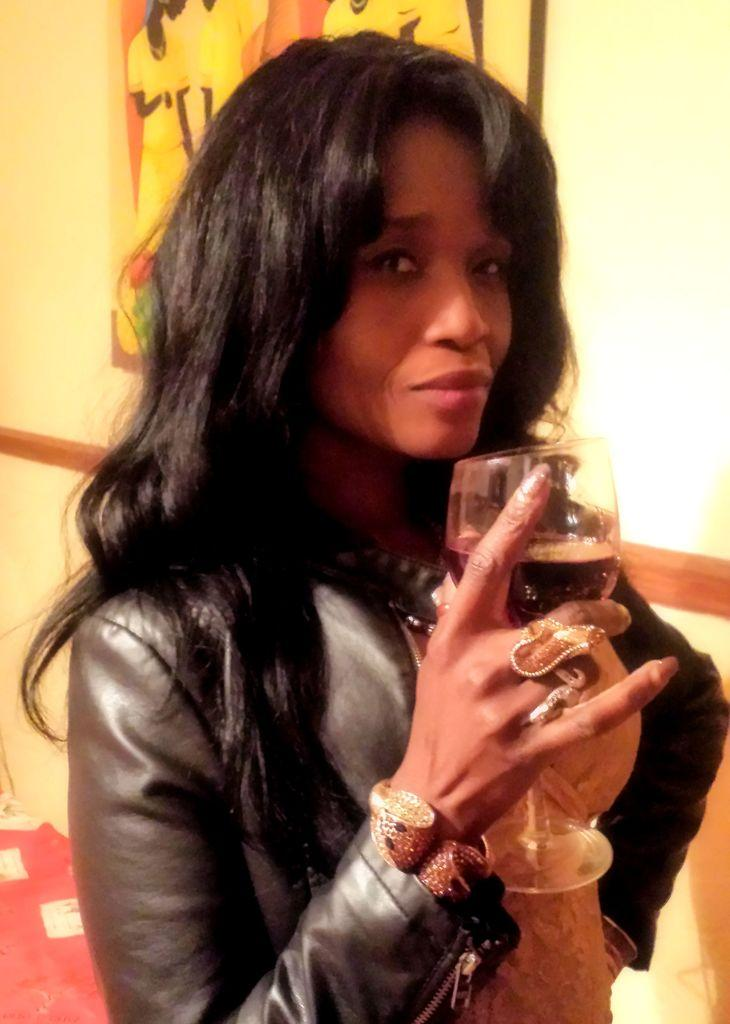What is the woman in the image doing? The woman is standing in the image. What is the woman wearing in the image? The woman is wearing a leather jacket. What is the woman holding in the image? The woman is holding a wine glass. What is in the wine glass? The wine glass contains wine. What can be seen in the background of the image? There is a poster in the background of the image. Where is the poster located? The poster is attached to a wall. What type of linen is draped over the woman's hand in the image? There is no linen draped over the woman's hand in the image. How many feet are visible in the image? The image only shows the woman standing, so only one foot is visible. 